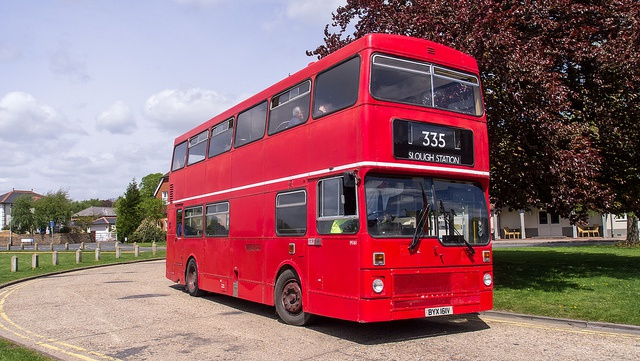Describe the objects in this image and their specific colors. I can see bus in lavender, red, brown, gray, and black tones, people in lavender and gray tones, bench in lavender, maroon, black, and tan tones, people in lavender, black, and gray tones, and people in lavender, black, and gray tones in this image. 